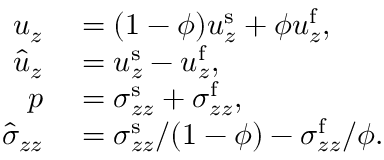Convert formula to latex. <formula><loc_0><loc_0><loc_500><loc_500>\begin{array} { r l } { u _ { z } } & = ( 1 - \phi ) u _ { z } ^ { s } + \phi u _ { z } ^ { f } , } \\ { \hat { u } _ { z } } & = u _ { z } ^ { s } - u _ { z } ^ { f } , } \\ { p } & = \sigma _ { z z } ^ { s } + \sigma _ { z z } ^ { f } , } \\ { \hat { \sigma } _ { z z } } & = \sigma _ { z z } ^ { s } / ( 1 - \phi ) - \sigma _ { z z } ^ { f } / \phi . } \end{array}</formula> 